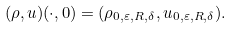Convert formula to latex. <formula><loc_0><loc_0><loc_500><loc_500>( \rho , u ) ( \cdot , 0 ) = ( \rho _ { 0 , \varepsilon , R , \delta } , u _ { 0 , \varepsilon , R , \delta } ) .</formula> 